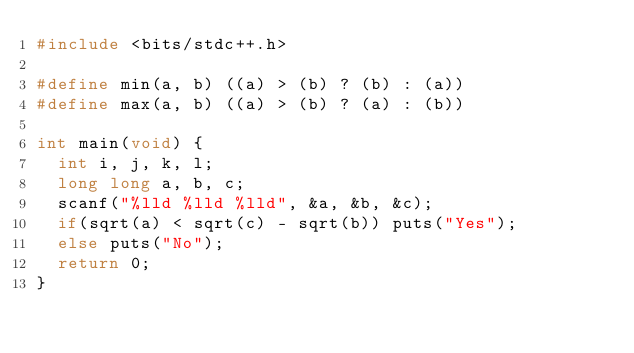Convert code to text. <code><loc_0><loc_0><loc_500><loc_500><_C++_>#include <bits/stdc++.h>

#define min(a, b) ((a) > (b) ? (b) : (a))
#define max(a, b) ((a) > (b) ? (a) : (b))

int main(void) {
  int i, j, k, l;
  long long a, b, c;
  scanf("%lld %lld %lld", &a, &b, &c);
  if(sqrt(a) < sqrt(c) - sqrt(b)) puts("Yes");
  else puts("No");
  return 0;
}
</code> 